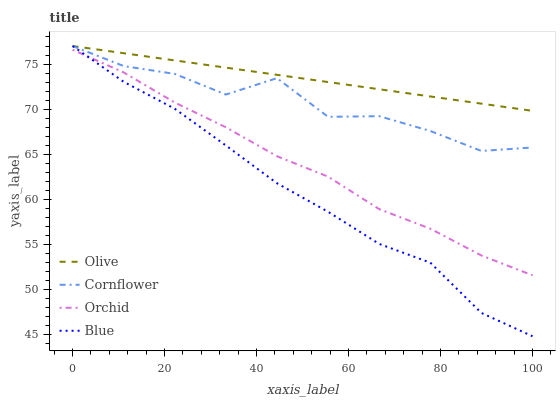Does Blue have the minimum area under the curve?
Answer yes or no. Yes. Does Olive have the maximum area under the curve?
Answer yes or no. Yes. Does Cornflower have the minimum area under the curve?
Answer yes or no. No. Does Cornflower have the maximum area under the curve?
Answer yes or no. No. Is Olive the smoothest?
Answer yes or no. Yes. Is Cornflower the roughest?
Answer yes or no. Yes. Is Blue the smoothest?
Answer yes or no. No. Is Blue the roughest?
Answer yes or no. No. Does Blue have the lowest value?
Answer yes or no. Yes. Does Cornflower have the lowest value?
Answer yes or no. No. Does Blue have the highest value?
Answer yes or no. Yes. Does Orchid have the highest value?
Answer yes or no. No. Is Orchid less than Cornflower?
Answer yes or no. Yes. Is Cornflower greater than Orchid?
Answer yes or no. Yes. Does Blue intersect Olive?
Answer yes or no. Yes. Is Blue less than Olive?
Answer yes or no. No. Is Blue greater than Olive?
Answer yes or no. No. Does Orchid intersect Cornflower?
Answer yes or no. No. 